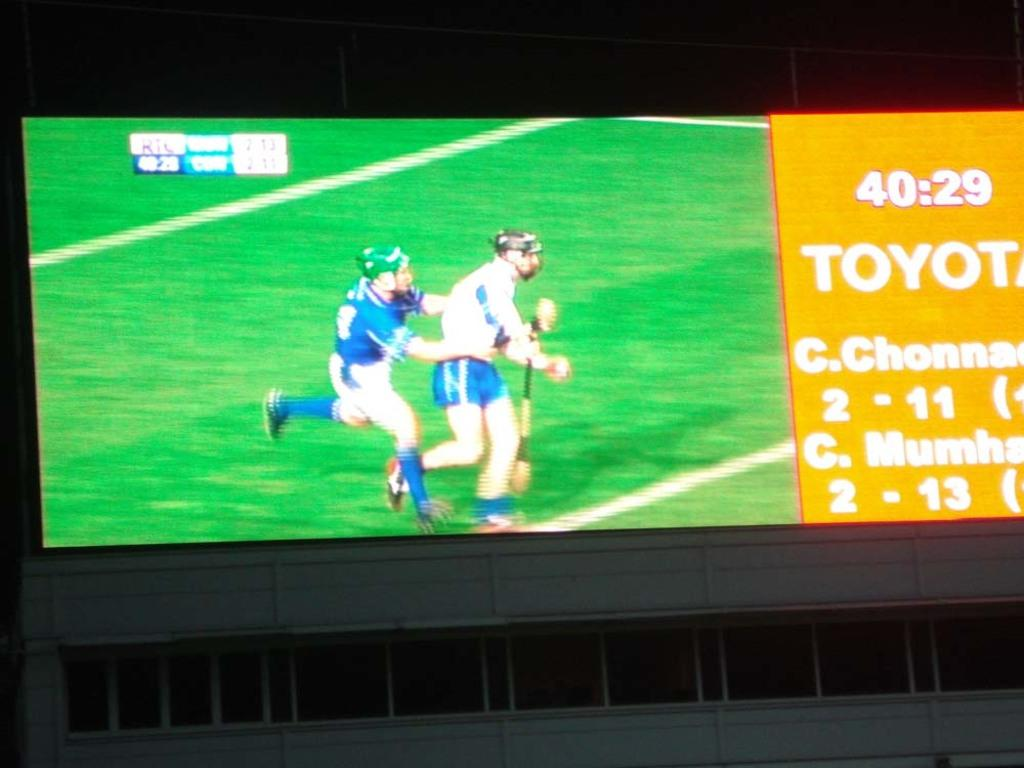<image>
Write a terse but informative summary of the picture. two men playing cricket and the time is 40:29 and Toyota is displayed. 